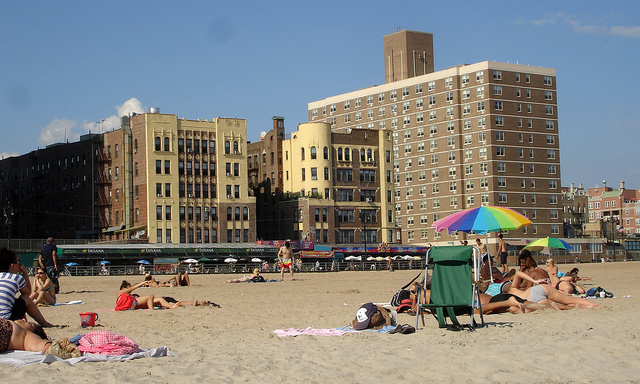What activities are people doing on this beach? From what I can see, there are several people sunbathing, lying on towels or beach mats. Some are seated on chairs, likely enjoying the ocean view or reading a book. It looks like a typical relaxing day at the beach with individuals and small groups lounging and enjoying the sun.  Can you tell me what time of day it might be at this beach? Given the length and position of the shadows seen in the image, along with the angle of sunlight and the amount of activity on the beach, it suggests that it might be either late morning or afternoon. It does not appear to be early morning or nearing sunset. 